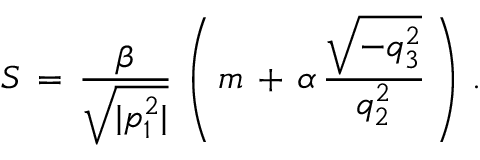Convert formula to latex. <formula><loc_0><loc_0><loc_500><loc_500>S \, = \, \frac { \beta } { \sqrt { | p _ { 1 } ^ { 2 } | } } \, \left ( \, m \, + \, \alpha \, \frac { \sqrt { - q _ { 3 } ^ { 2 } } } { q _ { 2 } ^ { 2 } } \, \right ) \, { . }</formula> 